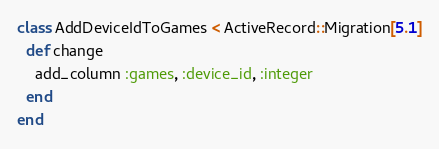Convert code to text. <code><loc_0><loc_0><loc_500><loc_500><_Ruby_>class AddDeviceIdToGames < ActiveRecord::Migration[5.1]
  def change
    add_column :games, :device_id, :integer
  end
end</code> 